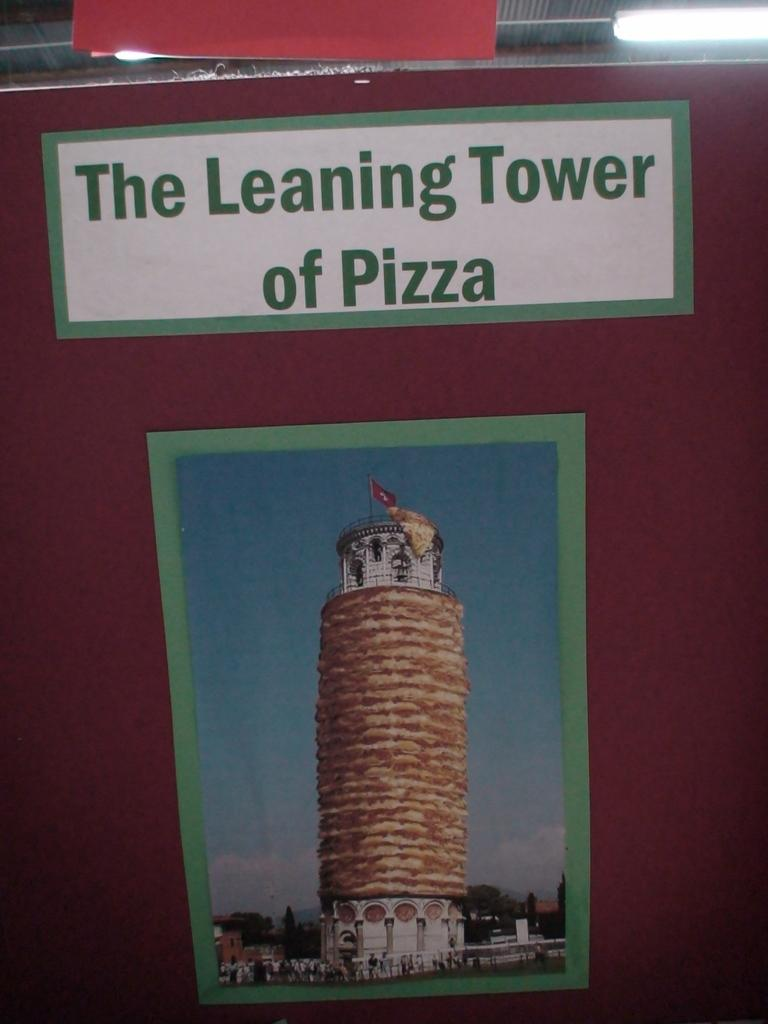What famous landmark is in the image? The Leaning Tower of Pisa is in the image. Are there any people near the landmark? Yes, there are people visible near the tower. What can be seen on top of the tower? Lights are seen on top of the tower. What type of stick is being distributed by the hands in the image? There are no hands or sticks present in the image; it features the Leaning Tower of Pisa with people nearby and lights on top. 